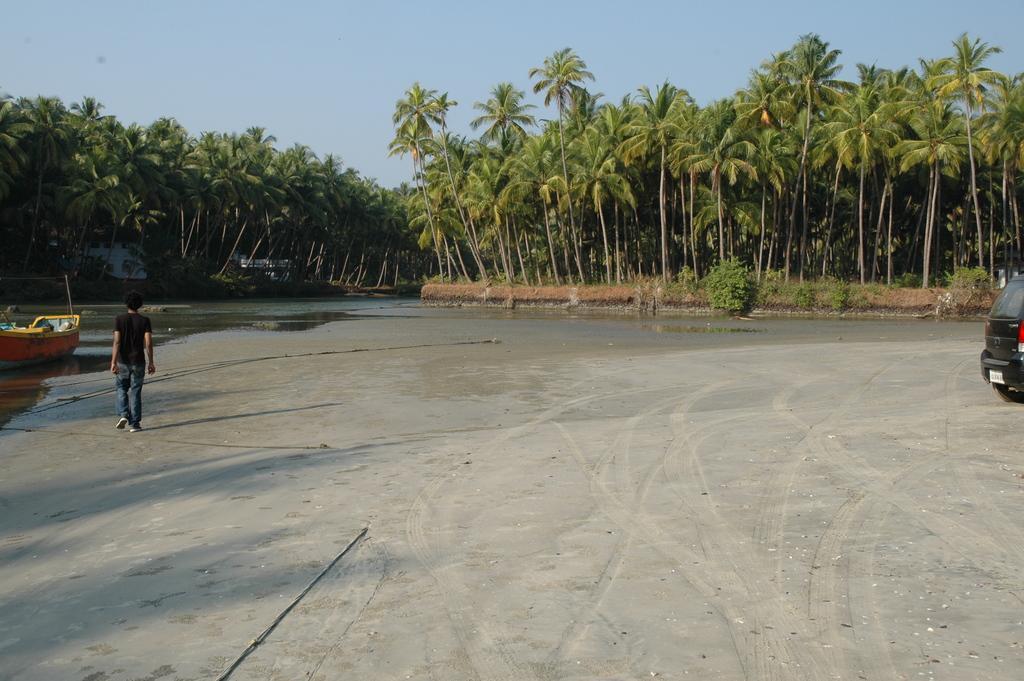Describe this image in one or two sentences. In this image I can see the ground, a person wearing black and blue colored dress is standing, the black colored car, the water, a boat on the surface of the water. In the background I can see few trees, few houses and the sky. 